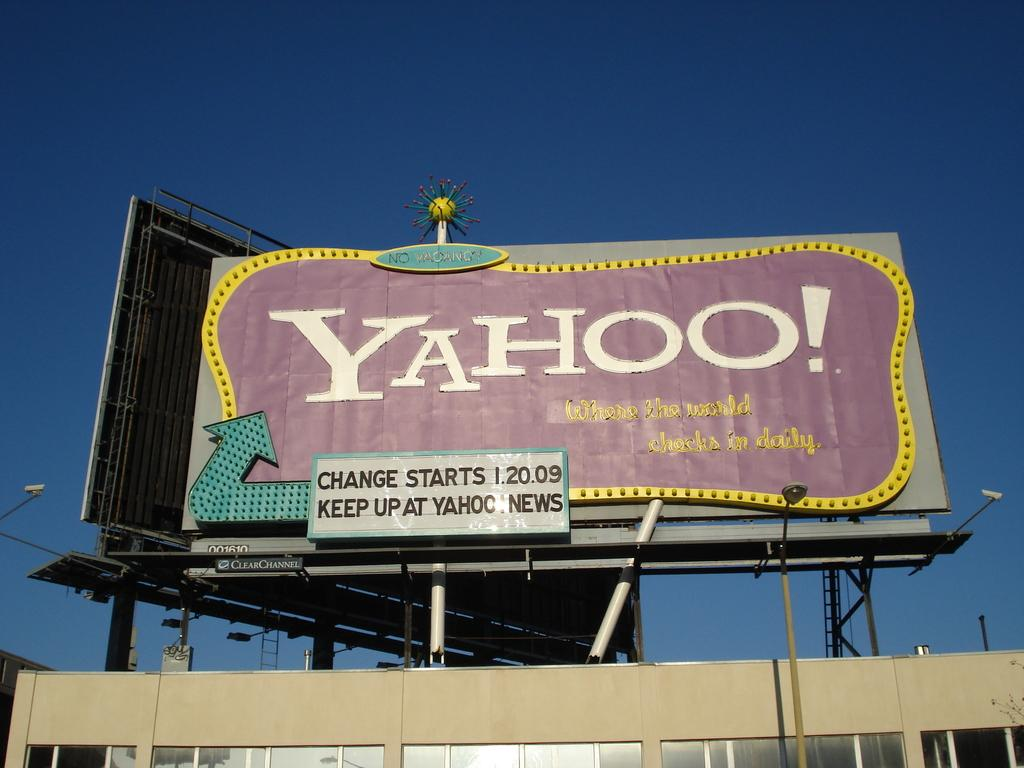Provide a one-sentence caption for the provided image. A billboard advertises that Yahoo! is changing as of January 20 2009. 